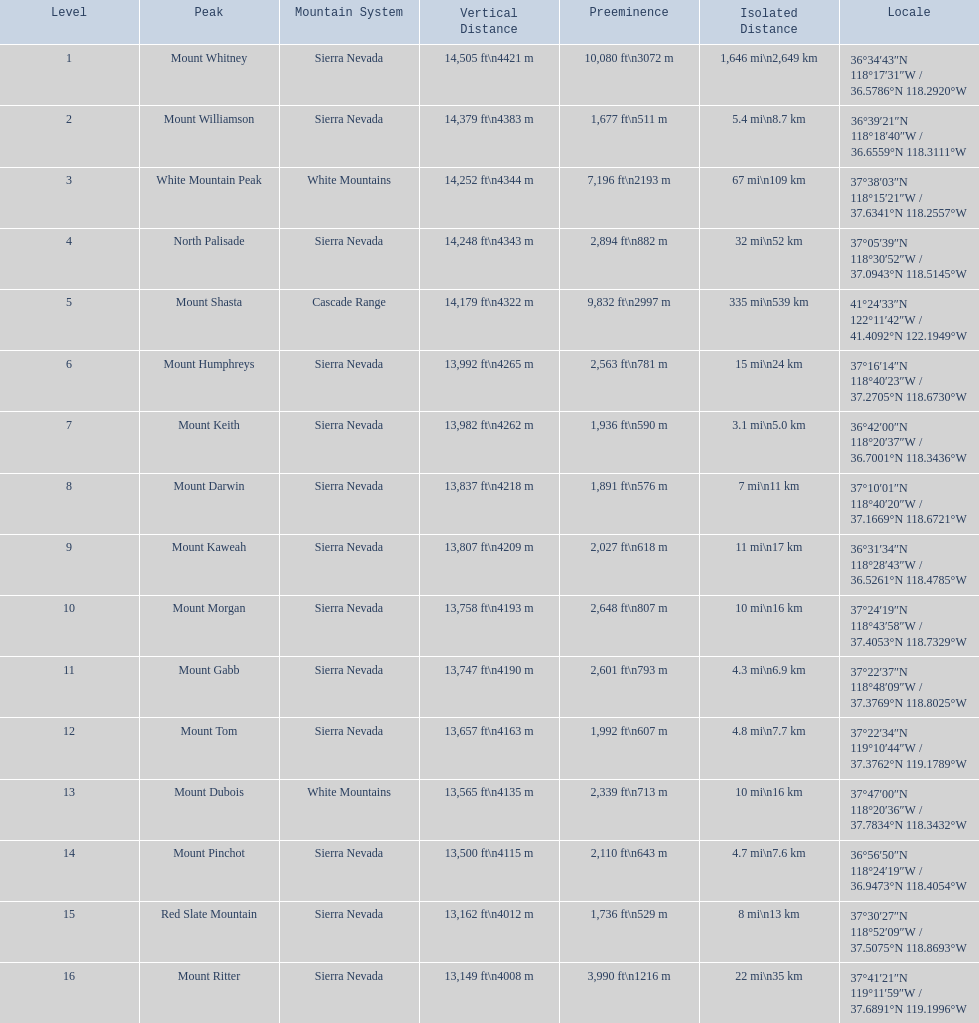Which mountain top possesses the most isolation? Mount Whitney. 